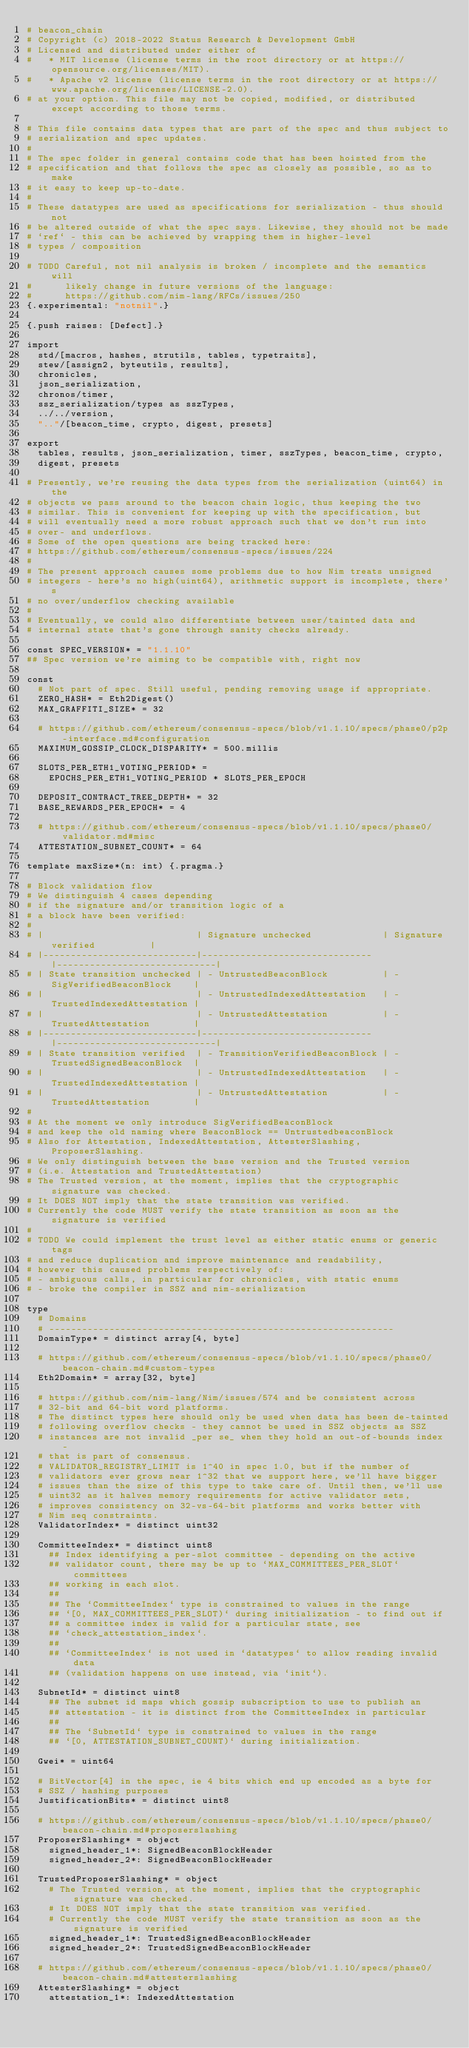<code> <loc_0><loc_0><loc_500><loc_500><_Nim_># beacon_chain
# Copyright (c) 2018-2022 Status Research & Development GmbH
# Licensed and distributed under either of
#   * MIT license (license terms in the root directory or at https://opensource.org/licenses/MIT).
#   * Apache v2 license (license terms in the root directory or at https://www.apache.org/licenses/LICENSE-2.0).
# at your option. This file may not be copied, modified, or distributed except according to those terms.

# This file contains data types that are part of the spec and thus subject to
# serialization and spec updates.
#
# The spec folder in general contains code that has been hoisted from the
# specification and that follows the spec as closely as possible, so as to make
# it easy to keep up-to-date.
#
# These datatypes are used as specifications for serialization - thus should not
# be altered outside of what the spec says. Likewise, they should not be made
# `ref` - this can be achieved by wrapping them in higher-level
# types / composition

# TODO Careful, not nil analysis is broken / incomplete and the semantics will
#      likely change in future versions of the language:
#      https://github.com/nim-lang/RFCs/issues/250
{.experimental: "notnil".}

{.push raises: [Defect].}

import
  std/[macros, hashes, strutils, tables, typetraits],
  stew/[assign2, byteutils, results],
  chronicles,
  json_serialization,
  chronos/timer,
  ssz_serialization/types as sszTypes,
  ../../version,
  ".."/[beacon_time, crypto, digest, presets]

export
  tables, results, json_serialization, timer, sszTypes, beacon_time, crypto,
  digest, presets

# Presently, we're reusing the data types from the serialization (uint64) in the
# objects we pass around to the beacon chain logic, thus keeping the two
# similar. This is convenient for keeping up with the specification, but
# will eventually need a more robust approach such that we don't run into
# over- and underflows.
# Some of the open questions are being tracked here:
# https://github.com/ethereum/consensus-specs/issues/224
#
# The present approach causes some problems due to how Nim treats unsigned
# integers - here's no high(uint64), arithmetic support is incomplete, there's
# no over/underflow checking available
#
# Eventually, we could also differentiate between user/tainted data and
# internal state that's gone through sanity checks already.

const SPEC_VERSION* = "1.1.10"
## Spec version we're aiming to be compatible with, right now

const
  # Not part of spec. Still useful, pending removing usage if appropriate.
  ZERO_HASH* = Eth2Digest()
  MAX_GRAFFITI_SIZE* = 32

  # https://github.com/ethereum/consensus-specs/blob/v1.1.10/specs/phase0/p2p-interface.md#configuration
  MAXIMUM_GOSSIP_CLOCK_DISPARITY* = 500.millis

  SLOTS_PER_ETH1_VOTING_PERIOD* =
    EPOCHS_PER_ETH1_VOTING_PERIOD * SLOTS_PER_EPOCH

  DEPOSIT_CONTRACT_TREE_DEPTH* = 32
  BASE_REWARDS_PER_EPOCH* = 4

  # https://github.com/ethereum/consensus-specs/blob/v1.1.10/specs/phase0/validator.md#misc
  ATTESTATION_SUBNET_COUNT* = 64

template maxSize*(n: int) {.pragma.}

# Block validation flow
# We distinguish 4 cases depending
# if the signature and/or transition logic of a
# a block have been verified:
#
# |                            | Signature unchecked             | Signature verified          |
# |----------------------------|-------------------------------  |-----------------------------|
# | State transition unchecked | - UntrustedBeaconBlock          | - SigVerifiedBeaconBlock    |
# |                            | - UntrustedIndexedAttestation   | - TrustedIndexedAttestation |
# |                            | - UntrustedAttestation          | - TrustedAttestation        |
# |----------------------------|-------------------------------  |-----------------------------|
# | State transition verified  | - TransitionVerifiedBeaconBlock | - TrustedSignedBeaconBlock  |
# |                            | - UntrustedIndexedAttestation   | - TrustedIndexedAttestation |
# |                            | - UntrustedAttestation          | - TrustedAttestation        |
#
# At the moment we only introduce SigVerifiedBeaconBlock
# and keep the old naming where BeaconBlock == UntrustedbeaconBlock
# Also for Attestation, IndexedAttestation, AttesterSlashing, ProposerSlashing.
# We only distinguish between the base version and the Trusted version
# (i.e. Attestation and TrustedAttestation)
# The Trusted version, at the moment, implies that the cryptographic signature was checked.
# It DOES NOT imply that the state transition was verified.
# Currently the code MUST verify the state transition as soon as the signature is verified
#
# TODO We could implement the trust level as either static enums or generic tags
# and reduce duplication and improve maintenance and readability,
# however this caused problems respectively of:
# - ambiguous calls, in particular for chronicles, with static enums
# - broke the compiler in SSZ and nim-serialization

type
  # Domains
  # ---------------------------------------------------------------
  DomainType* = distinct array[4, byte]

  # https://github.com/ethereum/consensus-specs/blob/v1.1.10/specs/phase0/beacon-chain.md#custom-types
  Eth2Domain* = array[32, byte]

  # https://github.com/nim-lang/Nim/issues/574 and be consistent across
  # 32-bit and 64-bit word platforms.
  # The distinct types here should only be used when data has been de-tainted
  # following overflow checks - they cannot be used in SSZ objects as SSZ
  # instances are not invalid _per se_ when they hold an out-of-bounds index -
  # that is part of consensus.
  # VALIDATOR_REGISTRY_LIMIT is 1^40 in spec 1.0, but if the number of
  # validators ever grows near 1^32 that we support here, we'll have bigger
  # issues than the size of this type to take care of. Until then, we'll use
  # uint32 as it halves memory requirements for active validator sets,
  # improves consistency on 32-vs-64-bit platforms and works better with
  # Nim seq constraints.
  ValidatorIndex* = distinct uint32

  CommitteeIndex* = distinct uint8
    ## Index identifying a per-slot committee - depending on the active
    ## validator count, there may be up to `MAX_COMMITTEES_PER_SLOT` committees
    ## working in each slot.
    ##
    ## The `CommitteeIndex` type is constrained to values in the range
    ## `[0, MAX_COMMITTEES_PER_SLOT)` during initialization - to find out if
    ## a committee index is valid for a particular state, see
    ## `check_attestation_index`.
    ##
    ## `CommitteeIndex` is not used in `datatypes` to allow reading invalid data
    ## (validation happens on use instead, via `init`).

  SubnetId* = distinct uint8
    ## The subnet id maps which gossip subscription to use to publish an
    ## attestation - it is distinct from the CommitteeIndex in particular
    ##
    ## The `SubnetId` type is constrained to values in the range
    ## `[0, ATTESTATION_SUBNET_COUNT)` during initialization.

  Gwei* = uint64

  # BitVector[4] in the spec, ie 4 bits which end up encoded as a byte for
  # SSZ / hashing purposes
  JustificationBits* = distinct uint8

  # https://github.com/ethereum/consensus-specs/blob/v1.1.10/specs/phase0/beacon-chain.md#proposerslashing
  ProposerSlashing* = object
    signed_header_1*: SignedBeaconBlockHeader
    signed_header_2*: SignedBeaconBlockHeader

  TrustedProposerSlashing* = object
    # The Trusted version, at the moment, implies that the cryptographic signature was checked.
    # It DOES NOT imply that the state transition was verified.
    # Currently the code MUST verify the state transition as soon as the signature is verified
    signed_header_1*: TrustedSignedBeaconBlockHeader
    signed_header_2*: TrustedSignedBeaconBlockHeader

  # https://github.com/ethereum/consensus-specs/blob/v1.1.10/specs/phase0/beacon-chain.md#attesterslashing
  AttesterSlashing* = object
    attestation_1*: IndexedAttestation</code> 